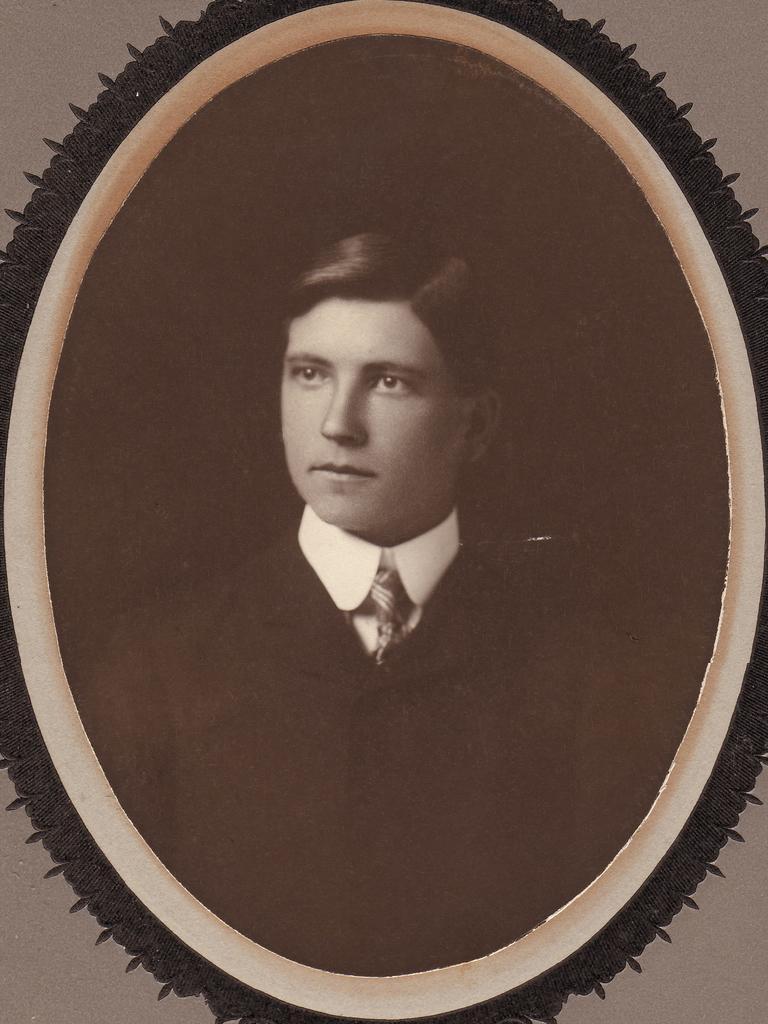In one or two sentences, can you explain what this image depicts? In this image in the center there is one photo frame, in that photo frame there is one person and in the background there is a wall. 